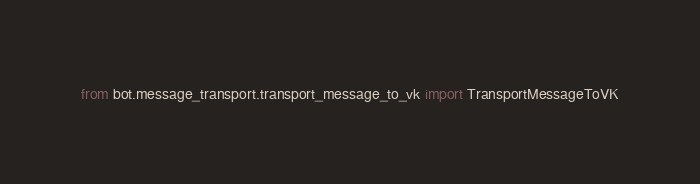Convert code to text. <code><loc_0><loc_0><loc_500><loc_500><_Python_>from bot.message_transport.transport_message_to_vk import TransportMessageToVK</code> 